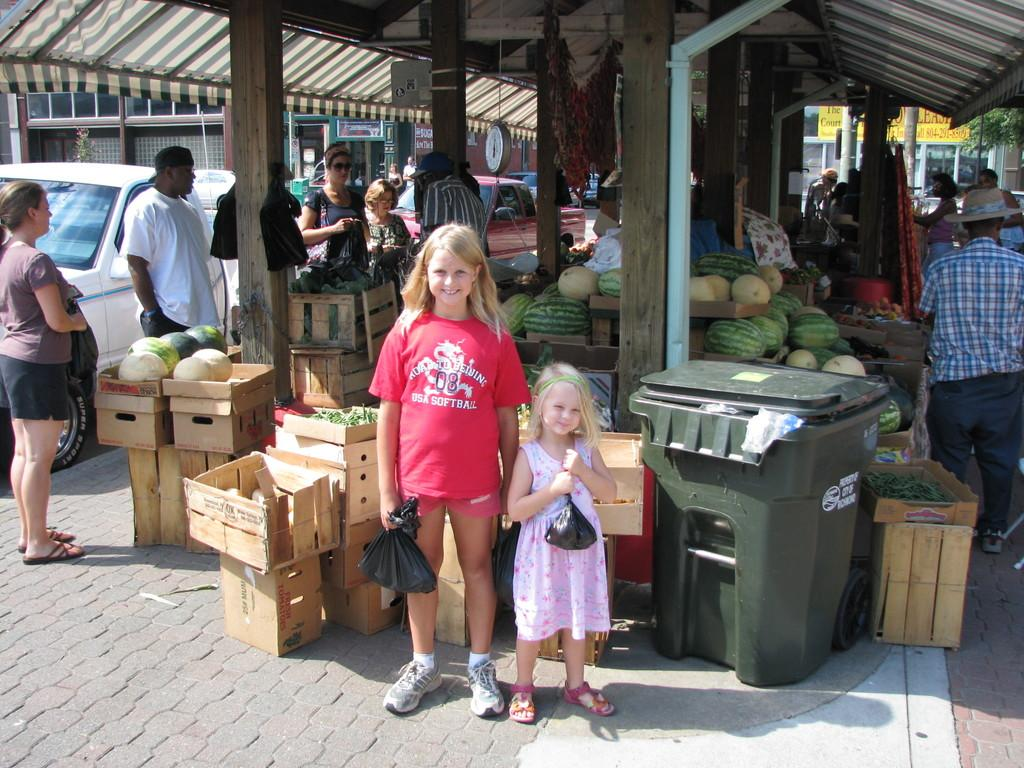<image>
Describe the image concisely. Two girls posing for a photo with one whose shirt says "USA SOFTBALL". 